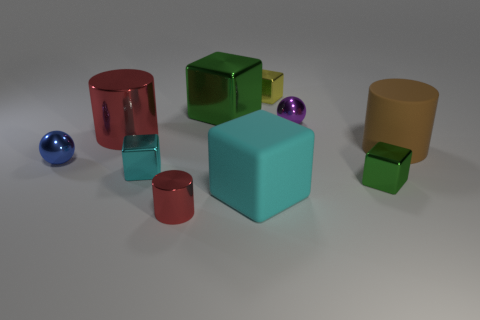Are the big cyan thing and the small ball to the right of the tiny red metal cylinder made of the same material?
Offer a very short reply. No. Are there fewer tiny red things that are behind the big brown cylinder than small metal cubes?
Offer a very short reply. Yes. What number of other things are there of the same shape as the big brown thing?
Your response must be concise. 2. Is there any other thing of the same color as the large shiny block?
Make the answer very short. Yes. There is a small cylinder; does it have the same color as the metal cylinder behind the big cyan block?
Give a very brief answer. Yes. How many other things are there of the same size as the cyan shiny cube?
Keep it short and to the point. 5. The metal object that is the same color as the large metal cylinder is what size?
Ensure brevity in your answer.  Small. What number of cylinders are tiny green things or small blue things?
Provide a short and direct response. 0. There is a metal thing that is on the left side of the large red metal cylinder; does it have the same shape as the tiny purple metal thing?
Your answer should be compact. Yes. Is the number of things that are right of the large green metal thing greater than the number of small green shiny cubes?
Your answer should be very brief. Yes. 